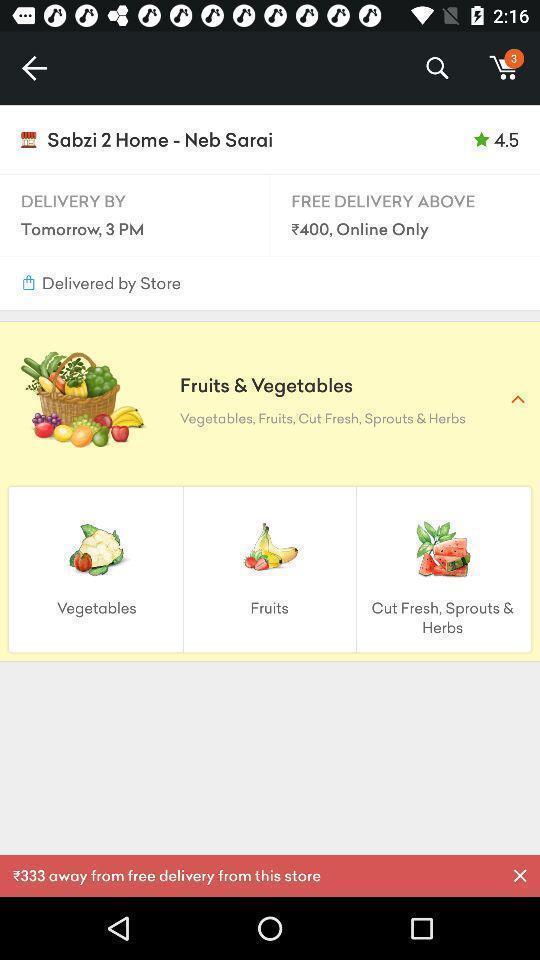Provide a detailed account of this screenshot. Screen showing grocery in a shopping app. 